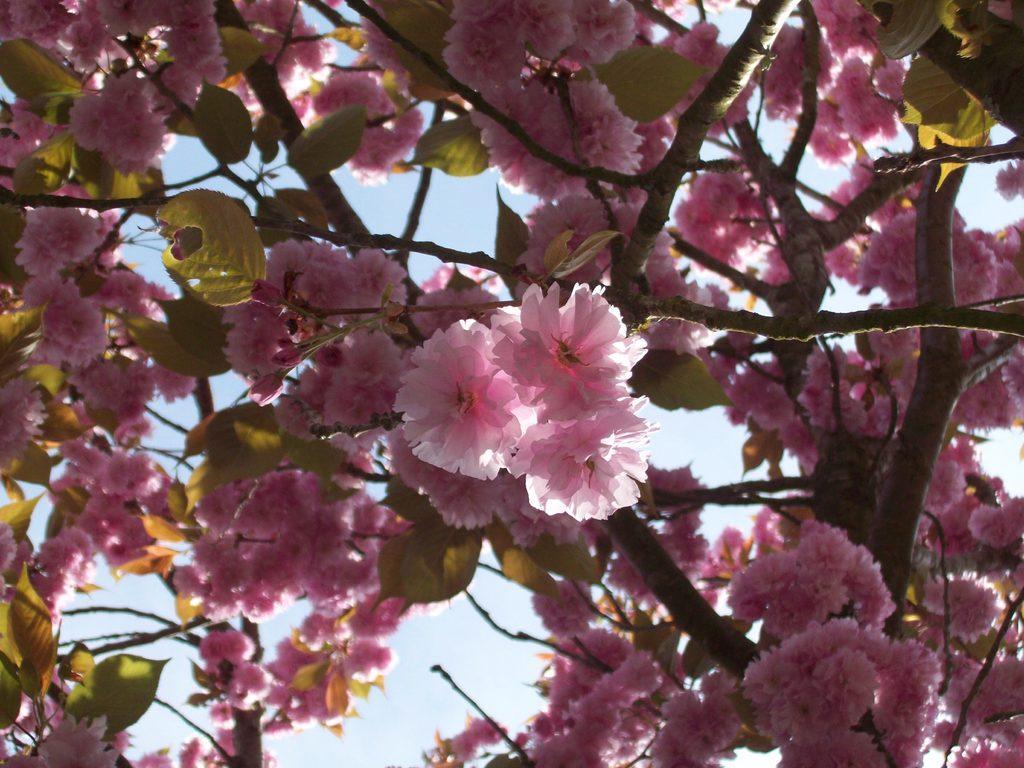Please provide a concise description of this image. In this image there is a tree with pink color flowers, and there is sky. 